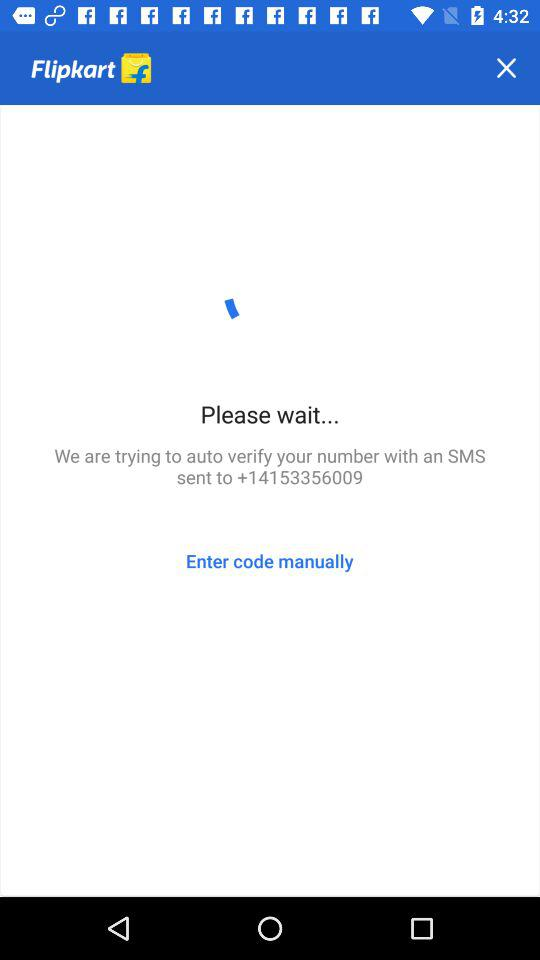What is the name of the application? The name of the application is "Flipkart". 